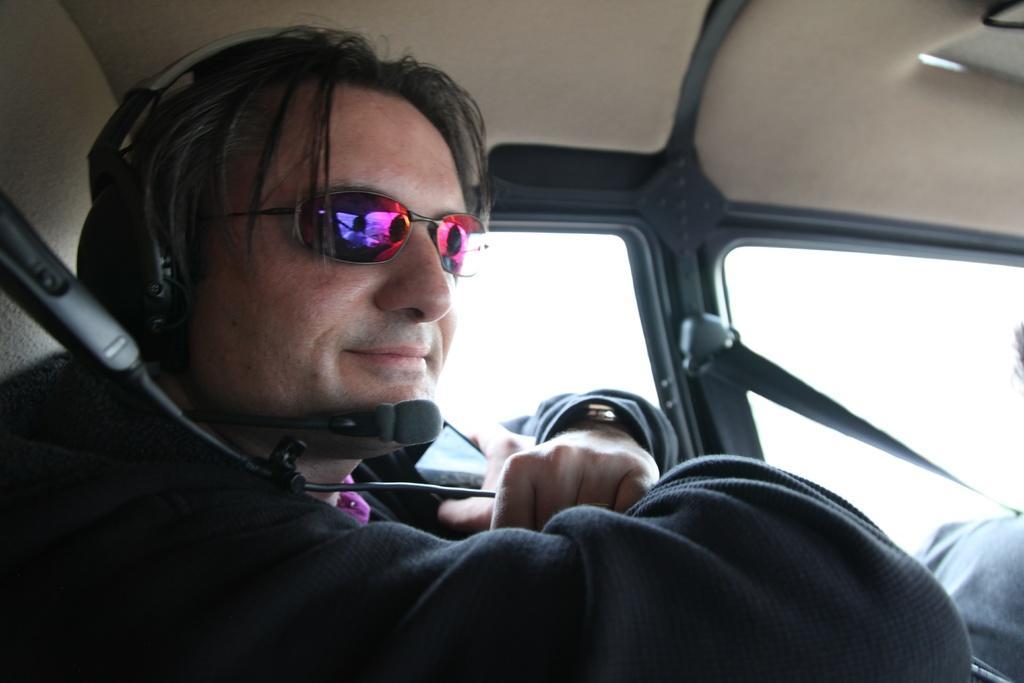Please provide a concise description of this image. This picture is clicked inside the vehicle. On the left there is a person wearing headphones, goggles and sitting in the vehicle. In the background we can see the windows and the roof of the vehicle. 